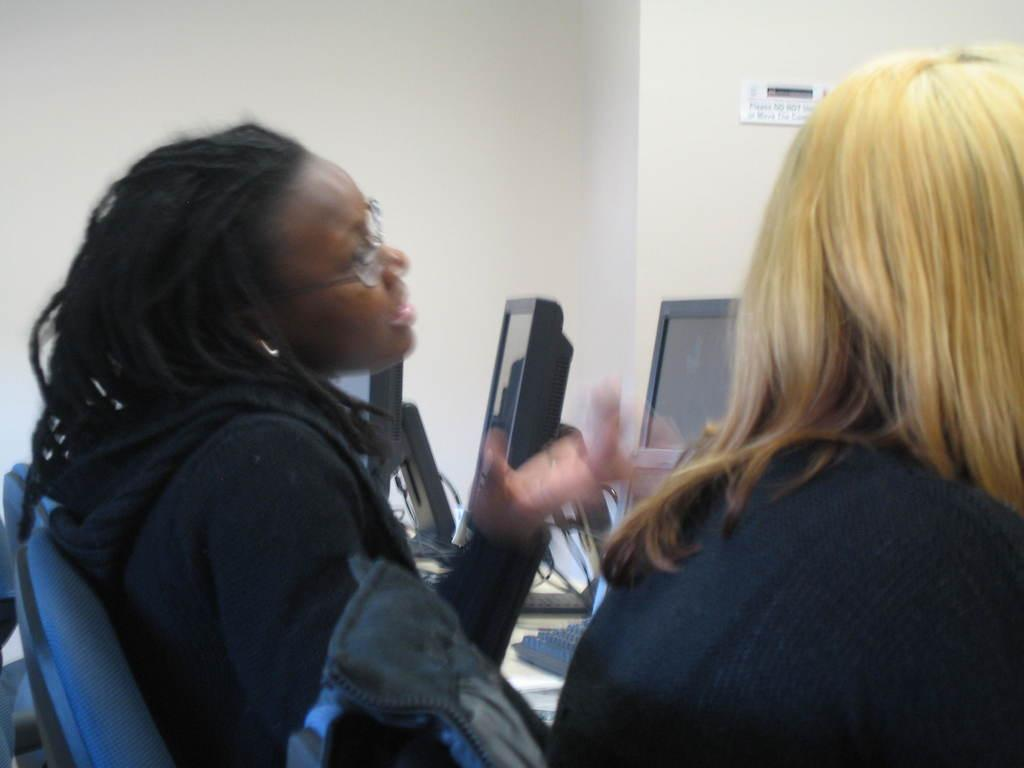How many people are in the image? There are 2 women in the image. What are the women doing in the image? The women are sitting. What can be seen in front of the women? There are 3 monitors in front of the women. What is visible in the background of the image? There is a wall in the background of the image. What type of territory is being claimed by the women in the image? There is no indication in the image that the women are claiming any territory. 